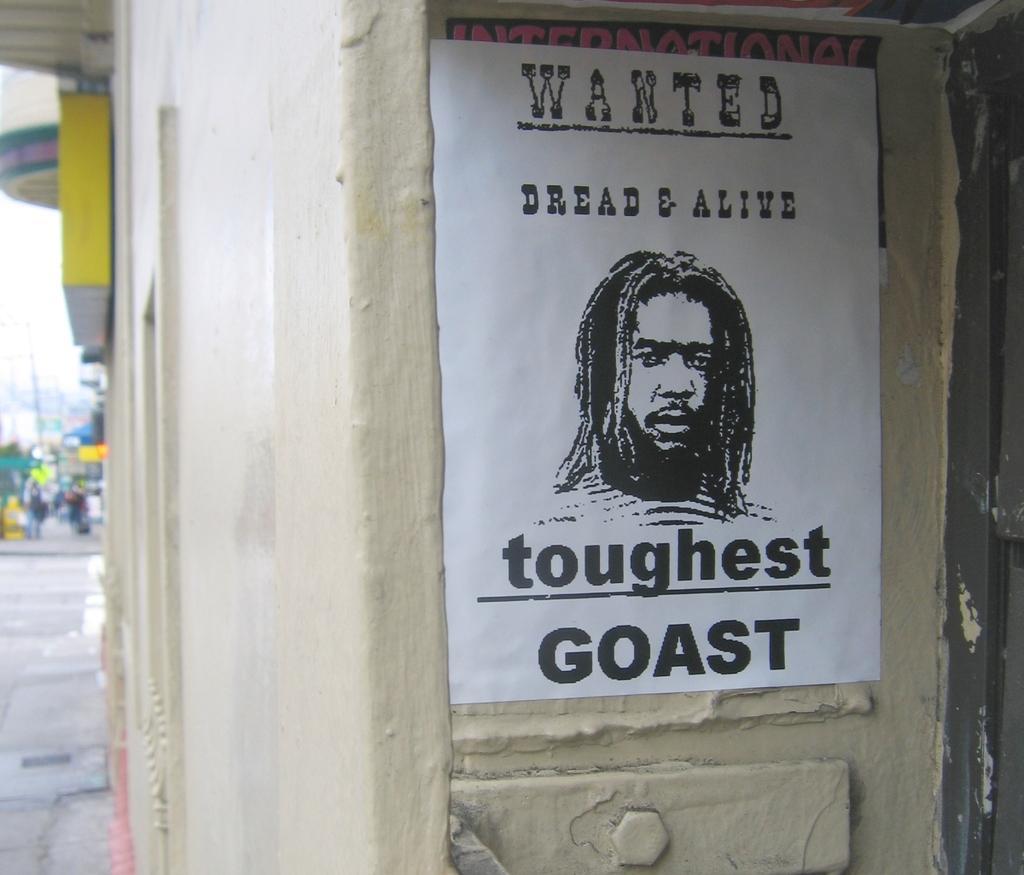Can you describe this image briefly? In this image we can see a poster on the wall on which we can see some text and a picture of a person. The background of the image is slightly blurred, where we can see board, people walking on the road and the sky. 